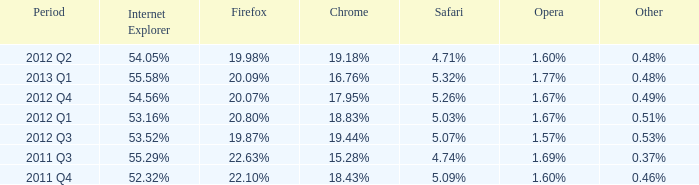What opera has 19.87% as the firefox? 1.57%. 